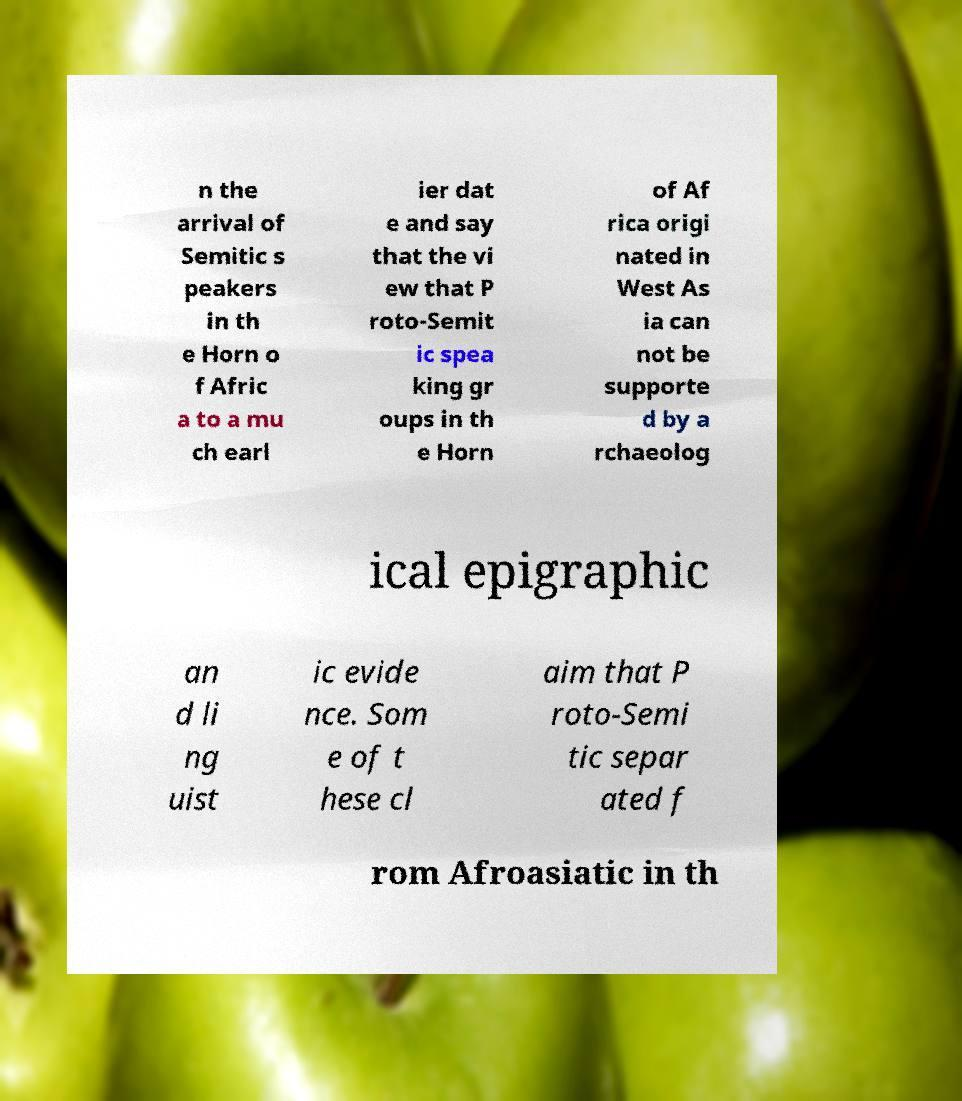There's text embedded in this image that I need extracted. Can you transcribe it verbatim? n the arrival of Semitic s peakers in th e Horn o f Afric a to a mu ch earl ier dat e and say that the vi ew that P roto-Semit ic spea king gr oups in th e Horn of Af rica origi nated in West As ia can not be supporte d by a rchaeolog ical epigraphic an d li ng uist ic evide nce. Som e of t hese cl aim that P roto-Semi tic separ ated f rom Afroasiatic in th 